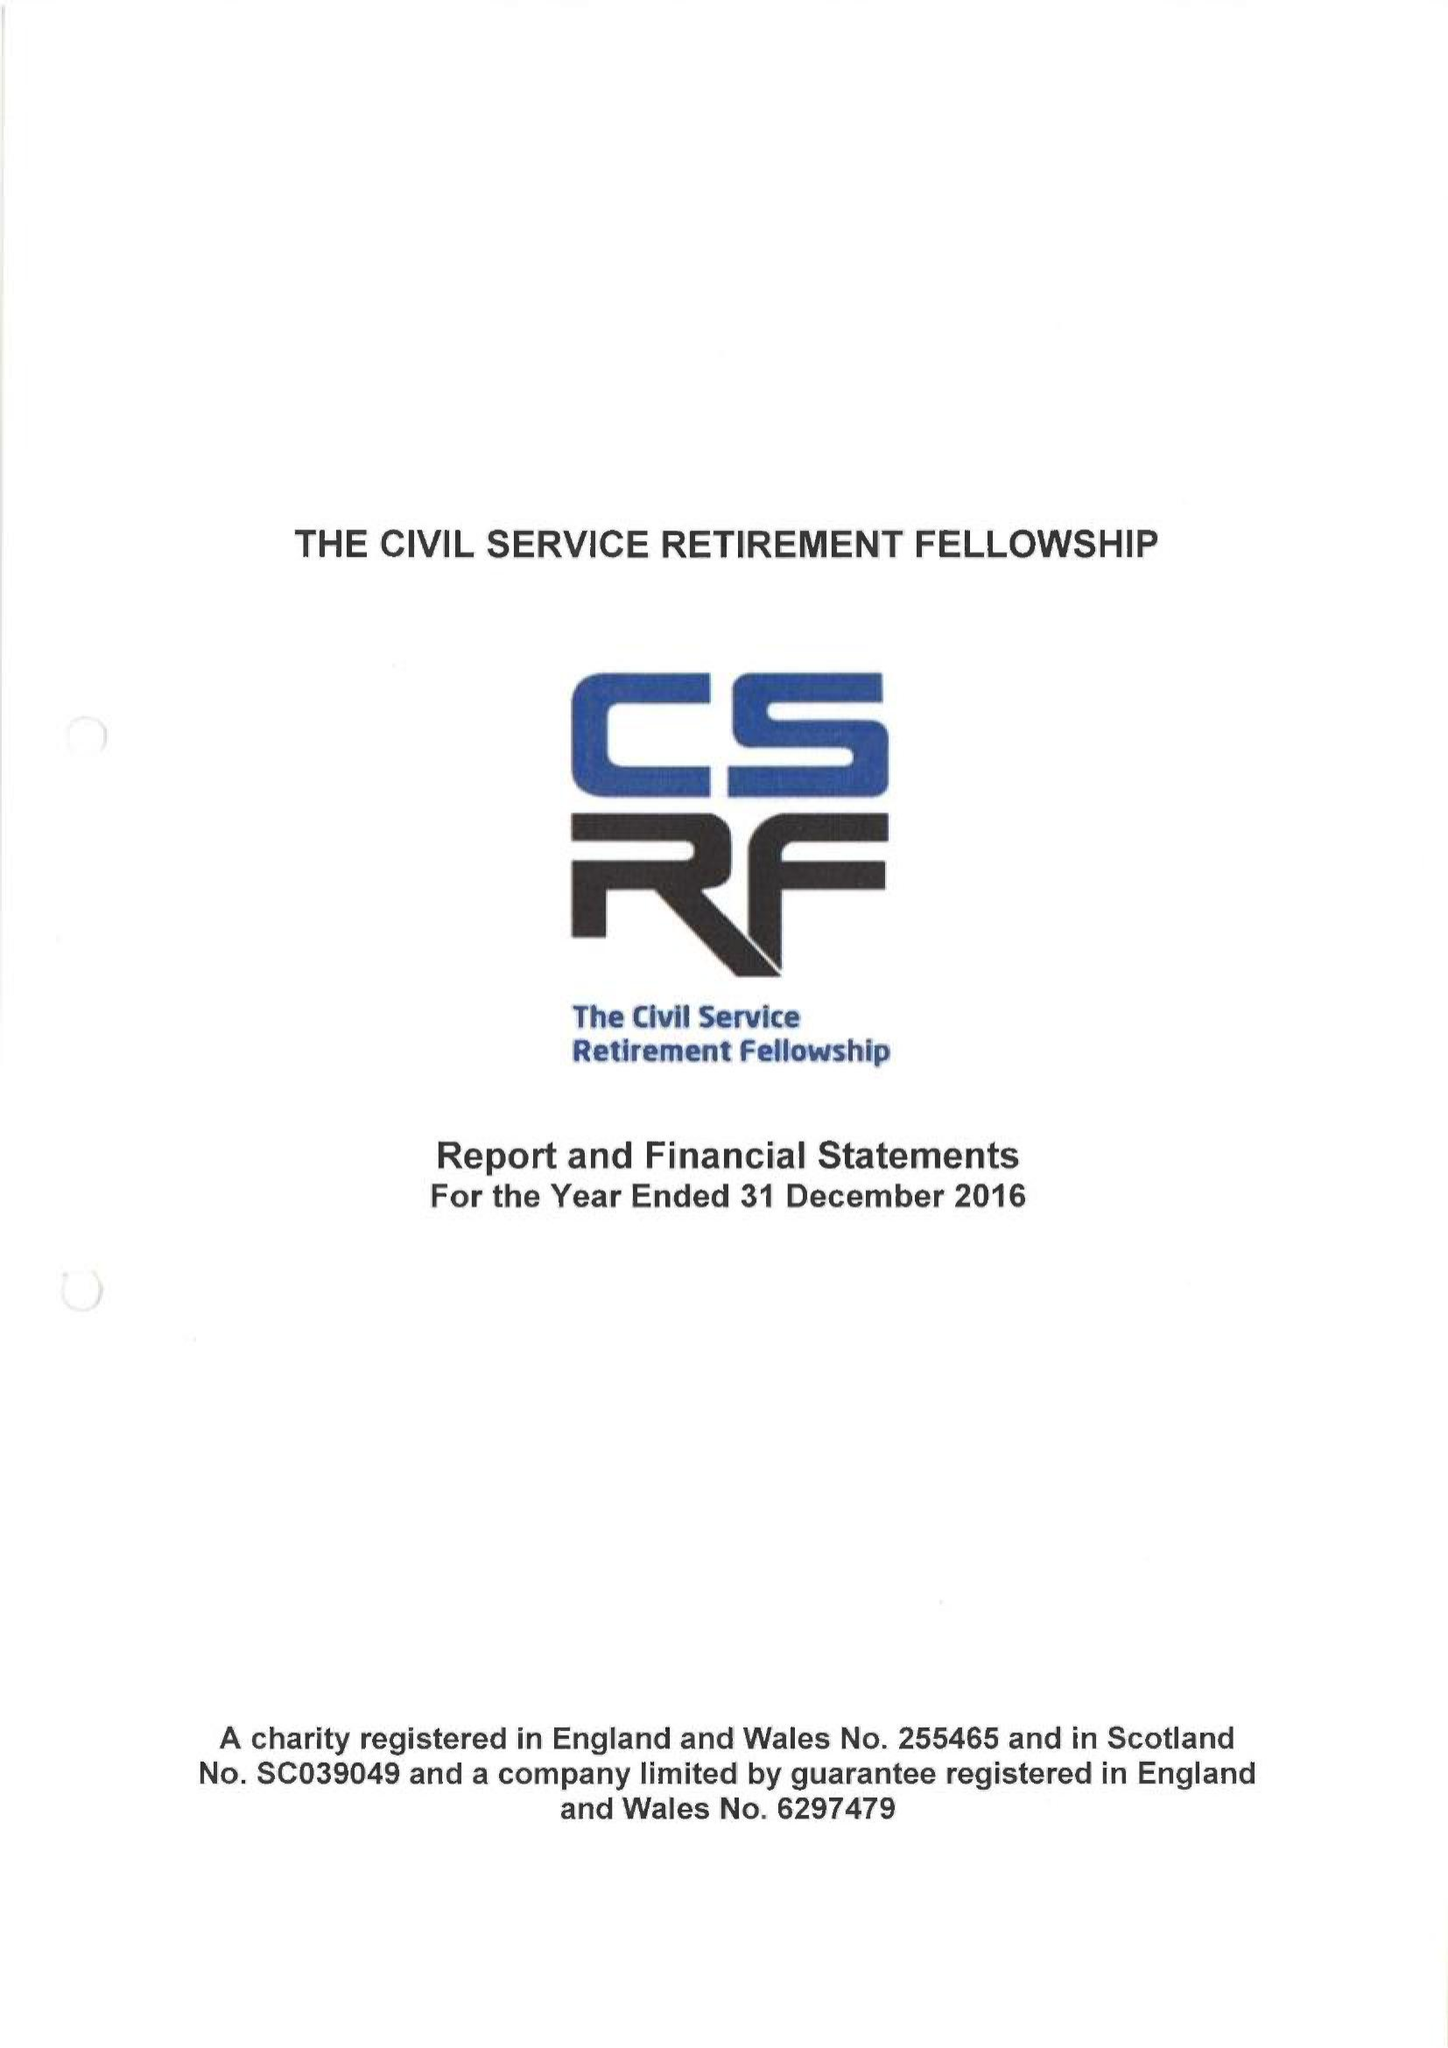What is the value for the charity_number?
Answer the question using a single word or phrase. 255465 